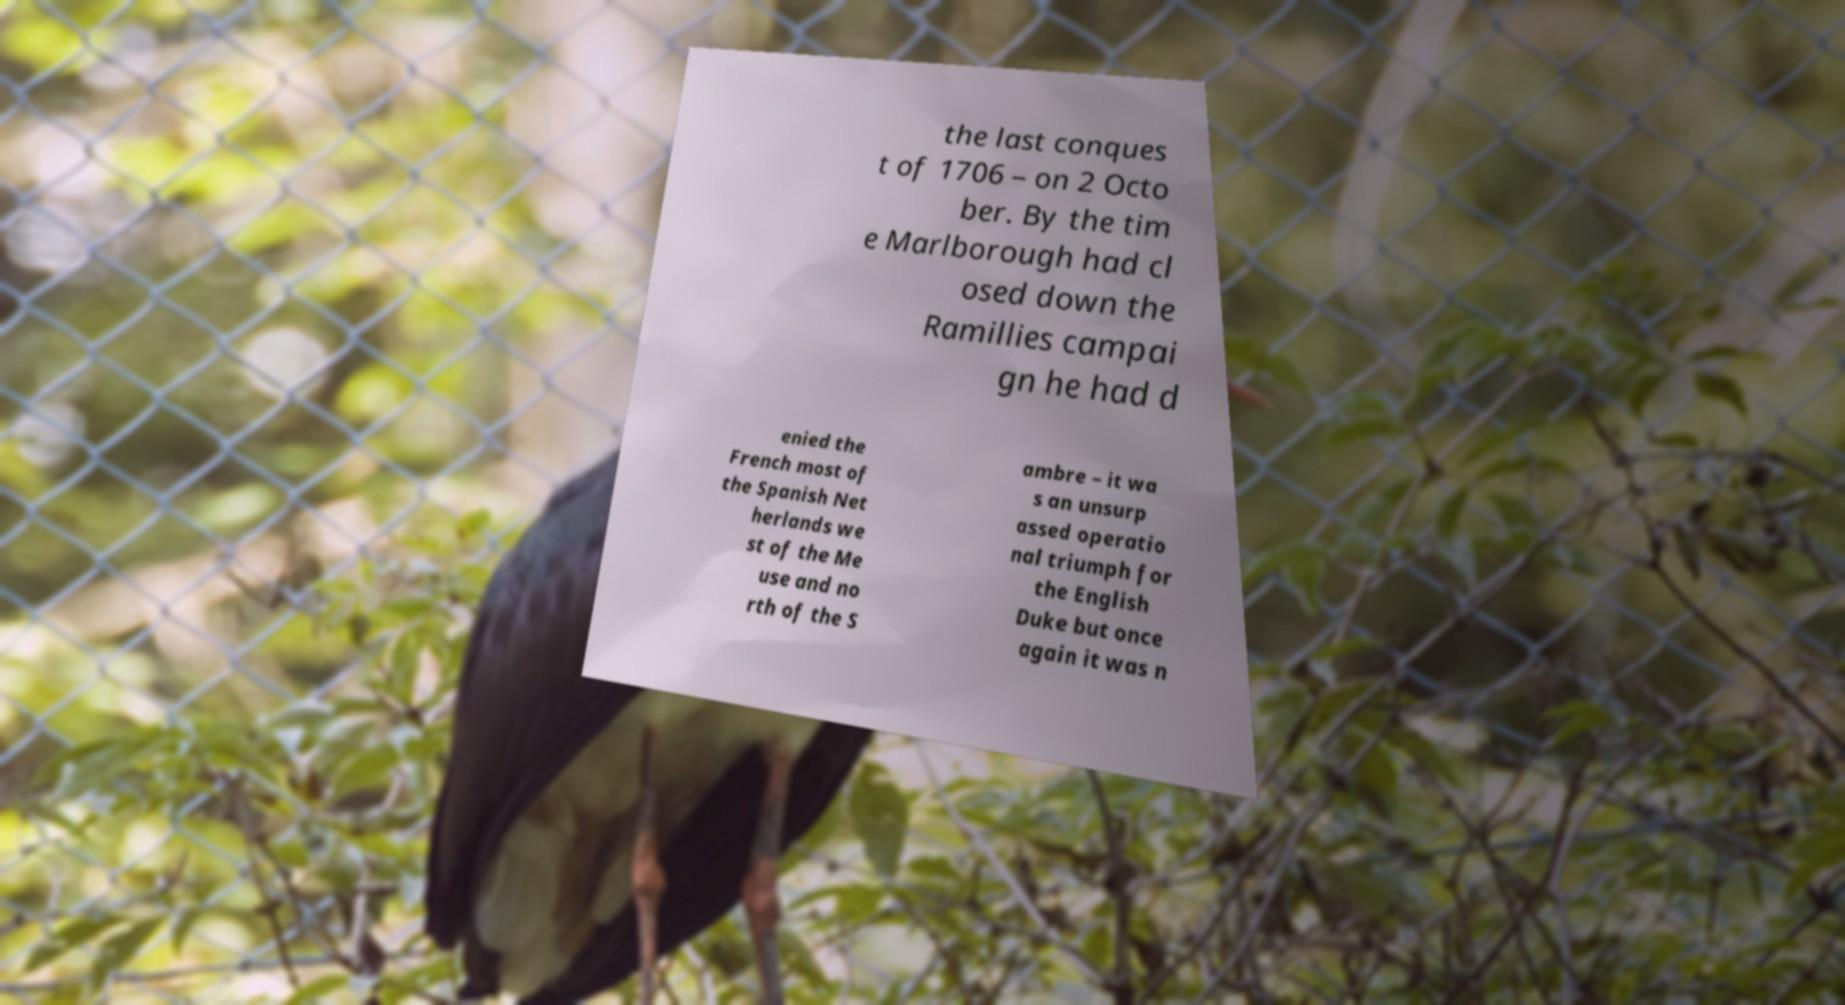For documentation purposes, I need the text within this image transcribed. Could you provide that? the last conques t of 1706 – on 2 Octo ber. By the tim e Marlborough had cl osed down the Ramillies campai gn he had d enied the French most of the Spanish Net herlands we st of the Me use and no rth of the S ambre – it wa s an unsurp assed operatio nal triumph for the English Duke but once again it was n 